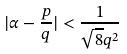<formula> <loc_0><loc_0><loc_500><loc_500>| \alpha - \frac { p } { q } | < \frac { 1 } { \sqrt { 8 } q ^ { 2 } }</formula> 